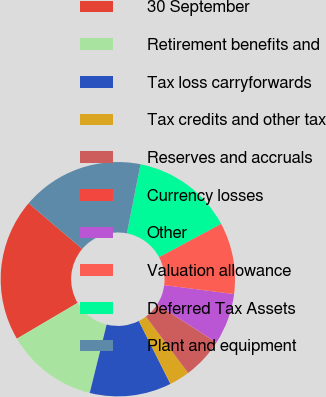<chart> <loc_0><loc_0><loc_500><loc_500><pie_chart><fcel>30 September<fcel>Retirement benefits and<fcel>Tax loss carryforwards<fcel>Tax credits and other tax<fcel>Reserves and accruals<fcel>Currency losses<fcel>Other<fcel>Valuation allowance<fcel>Deferred Tax Assets<fcel>Plant and equipment<nl><fcel>19.69%<fcel>12.67%<fcel>11.26%<fcel>2.84%<fcel>5.65%<fcel>0.03%<fcel>7.05%<fcel>9.86%<fcel>14.07%<fcel>16.88%<nl></chart> 